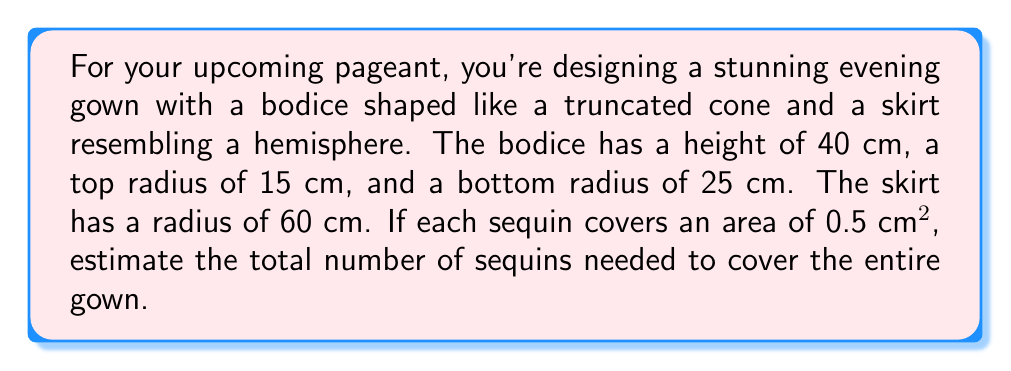Can you answer this question? Let's break this down step-by-step:

1. Calculate the surface area of the bodice (truncated cone):
   The lateral surface area of a truncated cone is given by:
   $$A_{cone} = \pi(r_1 + r_2)\sqrt{h^2 + (r_2 - r_1)^2}$$
   where $r_1$ is the top radius, $r_2$ is the bottom radius, and $h$ is the height.

   $$A_{cone} = \pi(15 + 25)\sqrt{40^2 + (25 - 15)^2}$$
   $$A_{cone} = 40\pi\sqrt{1600 + 100} = 40\pi\sqrt{1700} \approx 5215.17 \text{ cm}^2$$

2. Calculate the surface area of the skirt (hemisphere):
   The surface area of a hemisphere is given by:
   $$A_{hemisphere} = 2\pi r^2$$
   where $r$ is the radius.

   $$A_{hemisphere} = 2\pi(60)^2 = 7200\pi \approx 22619.47 \text{ cm}^2$$

3. Calculate the total surface area:
   $$A_{total} = A_{cone} + A_{hemisphere} \approx 5215.17 + 22619.47 = 27834.64 \text{ cm}^2$$

4. Calculate the number of sequins needed:
   Each sequin covers 0.5 cm², so divide the total area by 0.5:
   $$\text{Number of sequins} = \frac{A_{total}}{0.5} \approx \frac{27834.64}{0.5} = 55669.28$$

5. Round up to the nearest whole number:
   $$\text{Number of sequins} \approx 55670$$
Answer: 55670 sequins 